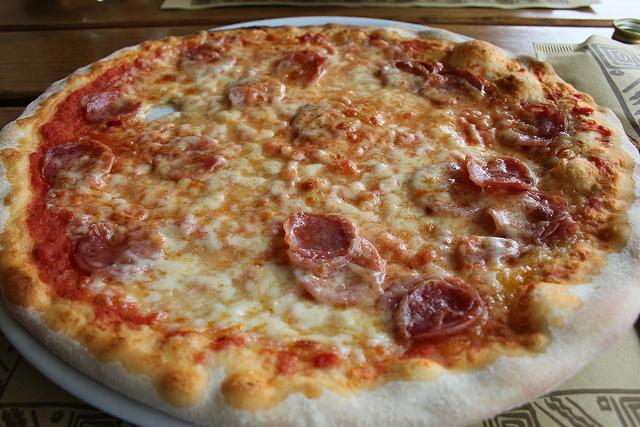Is this food?
Give a very brief answer. Yes. Has this been eaten?
Concise answer only. No. Is this food fattening?
Be succinct. Yes. What type of pizza?
Concise answer only. Pepperoni. 